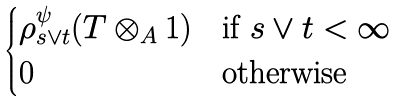<formula> <loc_0><loc_0><loc_500><loc_500>\begin{cases} \rho ^ { \psi } _ { s \vee t } ( T \otimes _ { A } 1 ) & \text {if $s\vee t < \infty$} \\ 0 & \text {otherwise} \end{cases}</formula> 